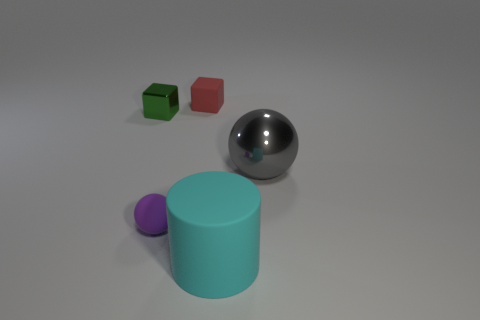What number of things are objects that are on the left side of the big cyan cylinder or tiny cubes that are behind the tiny shiny object?
Make the answer very short. 3. Are there fewer tiny purple things that are to the right of the tiny red rubber block than small brown shiny cubes?
Your answer should be compact. No. Do the cyan object and the ball that is in front of the large gray sphere have the same material?
Offer a very short reply. Yes. What is the material of the large cyan cylinder?
Make the answer very short. Rubber. There is a small thing that is in front of the metallic object that is left of the matte thing behind the green block; what is it made of?
Ensure brevity in your answer.  Rubber. Are there any other things that are the same shape as the big cyan rubber object?
Your answer should be compact. No. There is a object that is in front of the tiny matte object in front of the big gray sphere; what color is it?
Ensure brevity in your answer.  Cyan. How many big cyan blocks are there?
Offer a terse response. 0. What number of rubber things are either gray spheres or small balls?
Provide a short and direct response. 1. There is a small cube right of the rubber thing that is left of the rubber cube; what is its material?
Ensure brevity in your answer.  Rubber. 